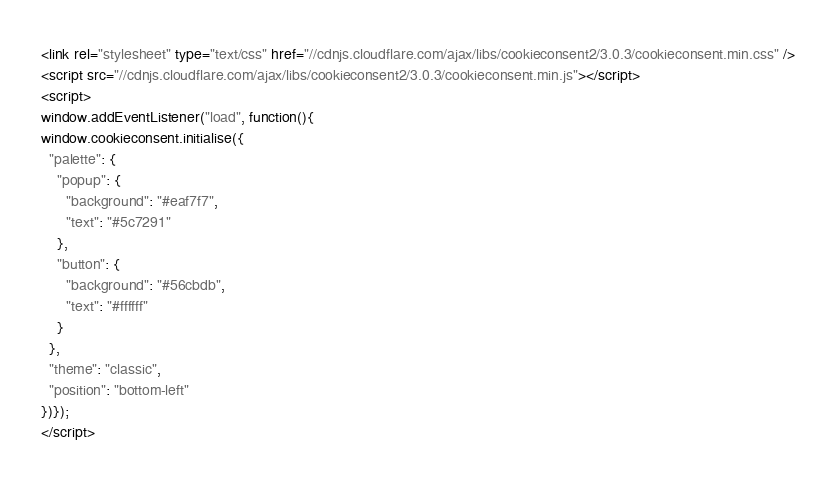Convert code to text. <code><loc_0><loc_0><loc_500><loc_500><_HTML_><link rel="stylesheet" type="text/css" href="//cdnjs.cloudflare.com/ajax/libs/cookieconsent2/3.0.3/cookieconsent.min.css" />
<script src="//cdnjs.cloudflare.com/ajax/libs/cookieconsent2/3.0.3/cookieconsent.min.js"></script>
<script>
window.addEventListener("load", function(){
window.cookieconsent.initialise({
  "palette": {
    "popup": {
      "background": "#eaf7f7",
      "text": "#5c7291"
    },
    "button": {
      "background": "#56cbdb",
      "text": "#ffffff"
    }
  },
  "theme": "classic",
  "position": "bottom-left"
})});
</script></code> 